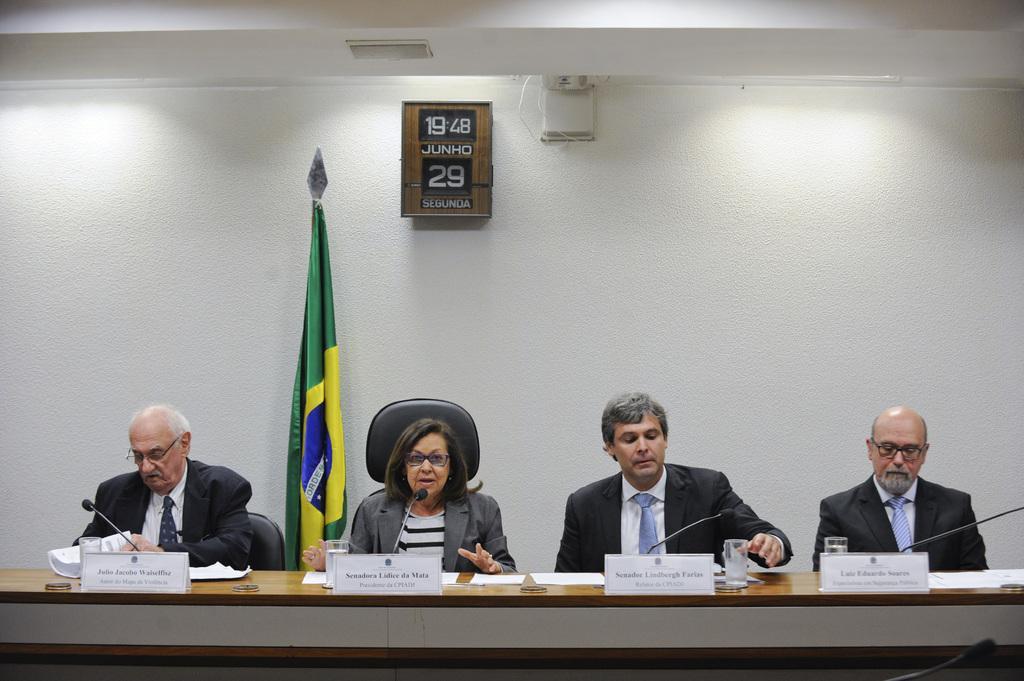Could you give a brief overview of what you see in this image? In this image we can see four persons. Behind the persons we can see a flag, wall and chairs. On the wall we can see an object. At the top we can see the roof. 